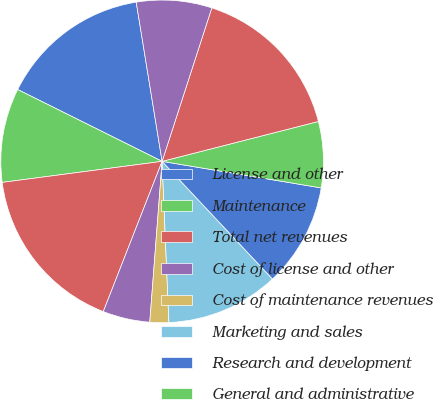<chart> <loc_0><loc_0><loc_500><loc_500><pie_chart><fcel>License and other<fcel>Maintenance<fcel>Total net revenues<fcel>Cost of license and other<fcel>Cost of maintenance revenues<fcel>Marketing and sales<fcel>Research and development<fcel>General and administrative<fcel>Total costs and expenses<fcel>Income from operations<nl><fcel>15.09%<fcel>9.43%<fcel>16.98%<fcel>4.72%<fcel>1.89%<fcel>11.32%<fcel>10.38%<fcel>6.61%<fcel>16.04%<fcel>7.55%<nl></chart> 